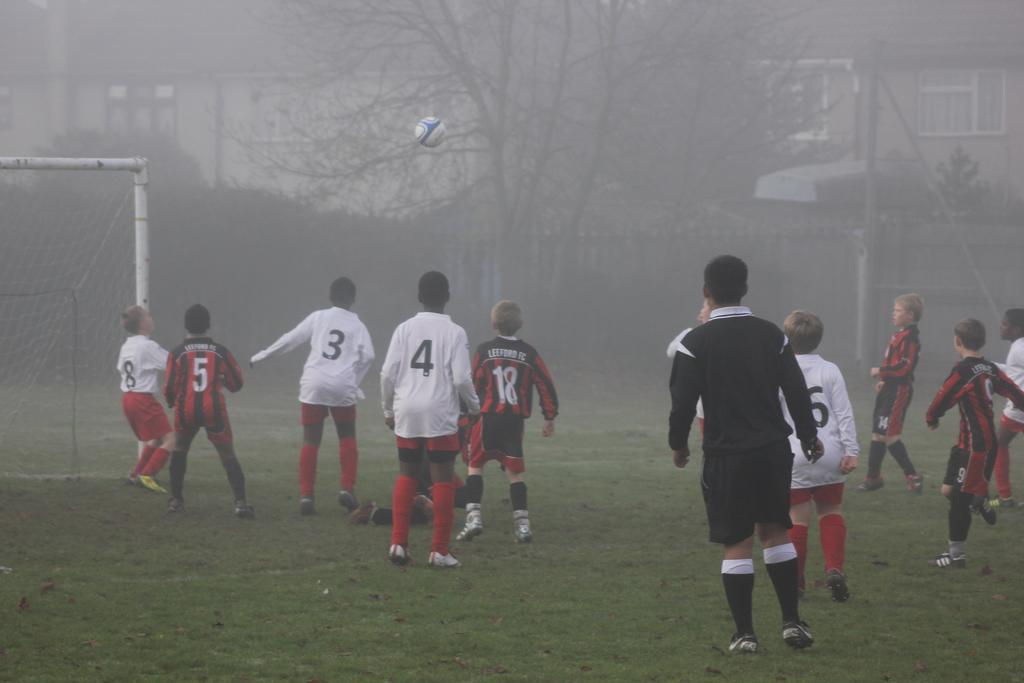<image>
Summarize the visual content of the image. Players on a foggy field wear jerseys with the numbers 5, 3, 4, 18, and more. 